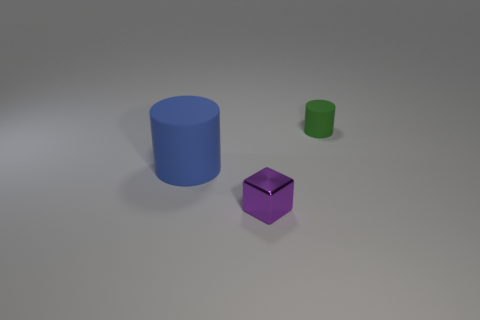What is the material of the green cylinder that is the same size as the purple object?
Make the answer very short. Rubber. Is there a purple object that is on the right side of the rubber object that is right of the large blue rubber object?
Make the answer very short. No. How many other things are there of the same color as the block?
Provide a short and direct response. 0. What size is the blue cylinder?
Provide a succinct answer. Large. Are any green rubber things visible?
Provide a succinct answer. Yes. Is the number of large blue matte things to the right of the small purple object greater than the number of blue objects that are on the right side of the large blue rubber thing?
Keep it short and to the point. No. What is the material of the thing that is in front of the tiny green cylinder and to the right of the big matte thing?
Make the answer very short. Metal. Do the small matte object and the large thing have the same shape?
Give a very brief answer. Yes. Is there any other thing that has the same size as the metal cube?
Offer a very short reply. Yes. There is a large blue rubber cylinder; what number of blue cylinders are behind it?
Give a very brief answer. 0. 